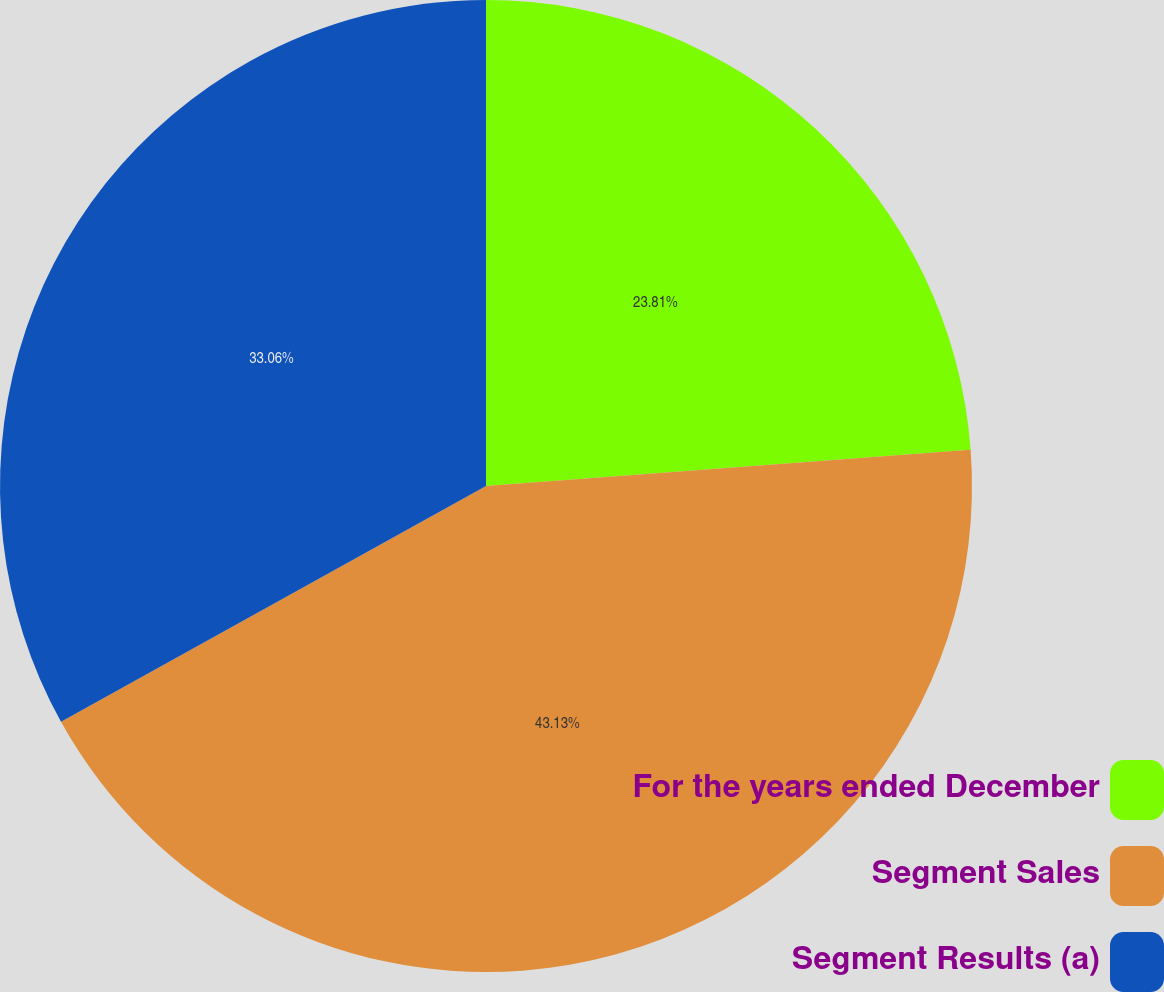<chart> <loc_0><loc_0><loc_500><loc_500><pie_chart><fcel>For the years ended December<fcel>Segment Sales<fcel>Segment Results (a)<nl><fcel>23.81%<fcel>43.13%<fcel>33.06%<nl></chart> 